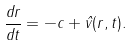Convert formula to latex. <formula><loc_0><loc_0><loc_500><loc_500>\frac { d r } { d t } = - c + \hat { v } ( r , t ) .</formula> 